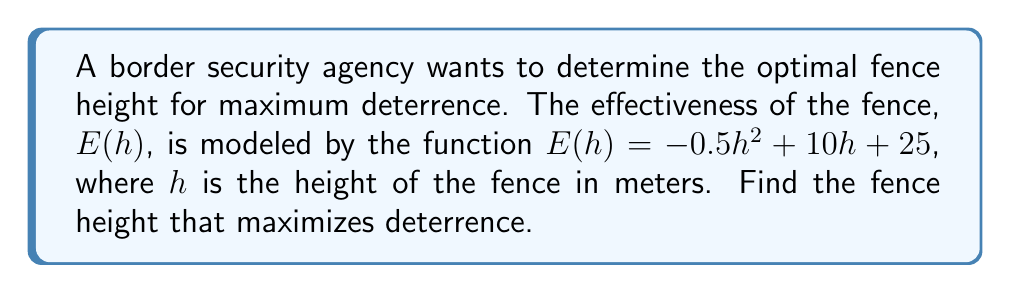Give your solution to this math problem. To find the optimal fence height that maximizes deterrence, we need to find the maximum value of the function $E(h)$. This can be done by finding the critical point where the derivative of $E(h)$ equals zero.

Step 1: Find the derivative of $E(h)$.
$$E'(h) = \frac{d}{dh}(-0.5h^2 + 10h + 25) = -h + 10$$

Step 2: Set the derivative equal to zero and solve for $h$.
$$E'(h) = 0$$
$$-h + 10 = 0$$
$$h = 10$$

Step 3: Verify that this critical point is a maximum by checking the second derivative.
$$E''(h) = \frac{d}{dh}(-h + 10) = -1$$

Since $E''(h) < 0$ for all $h$, the critical point $h = 10$ is indeed a maximum.

Therefore, the fence height that maximizes deterrence is 10 meters.
Answer: 10 meters 